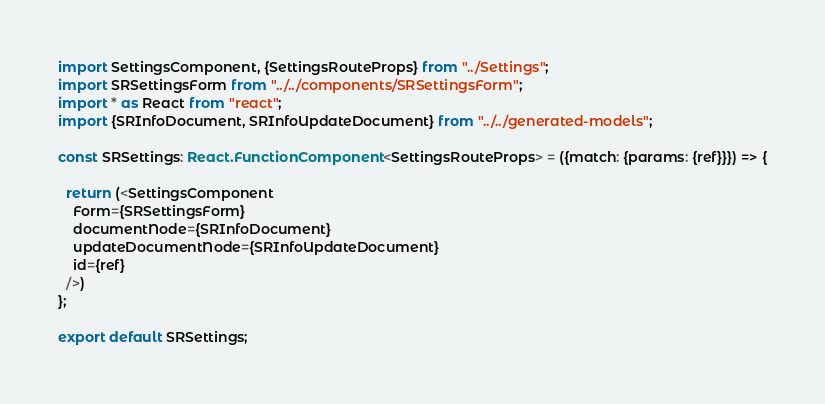<code> <loc_0><loc_0><loc_500><loc_500><_TypeScript_>import SettingsComponent, {SettingsRouteProps} from "../Settings";
import SRSettingsForm from "../../components/SRSettingsForm";
import * as React from "react";
import {SRInfoDocument, SRInfoUpdateDocument} from "../../generated-models";

const SRSettings: React.FunctionComponent<SettingsRouteProps> = ({match: {params: {ref}}}) => {

  return (<SettingsComponent
    Form={SRSettingsForm}
    documentNode={SRInfoDocument}
    updateDocumentNode={SRInfoUpdateDocument}
    id={ref}
  />)
};

export default SRSettings;
</code> 